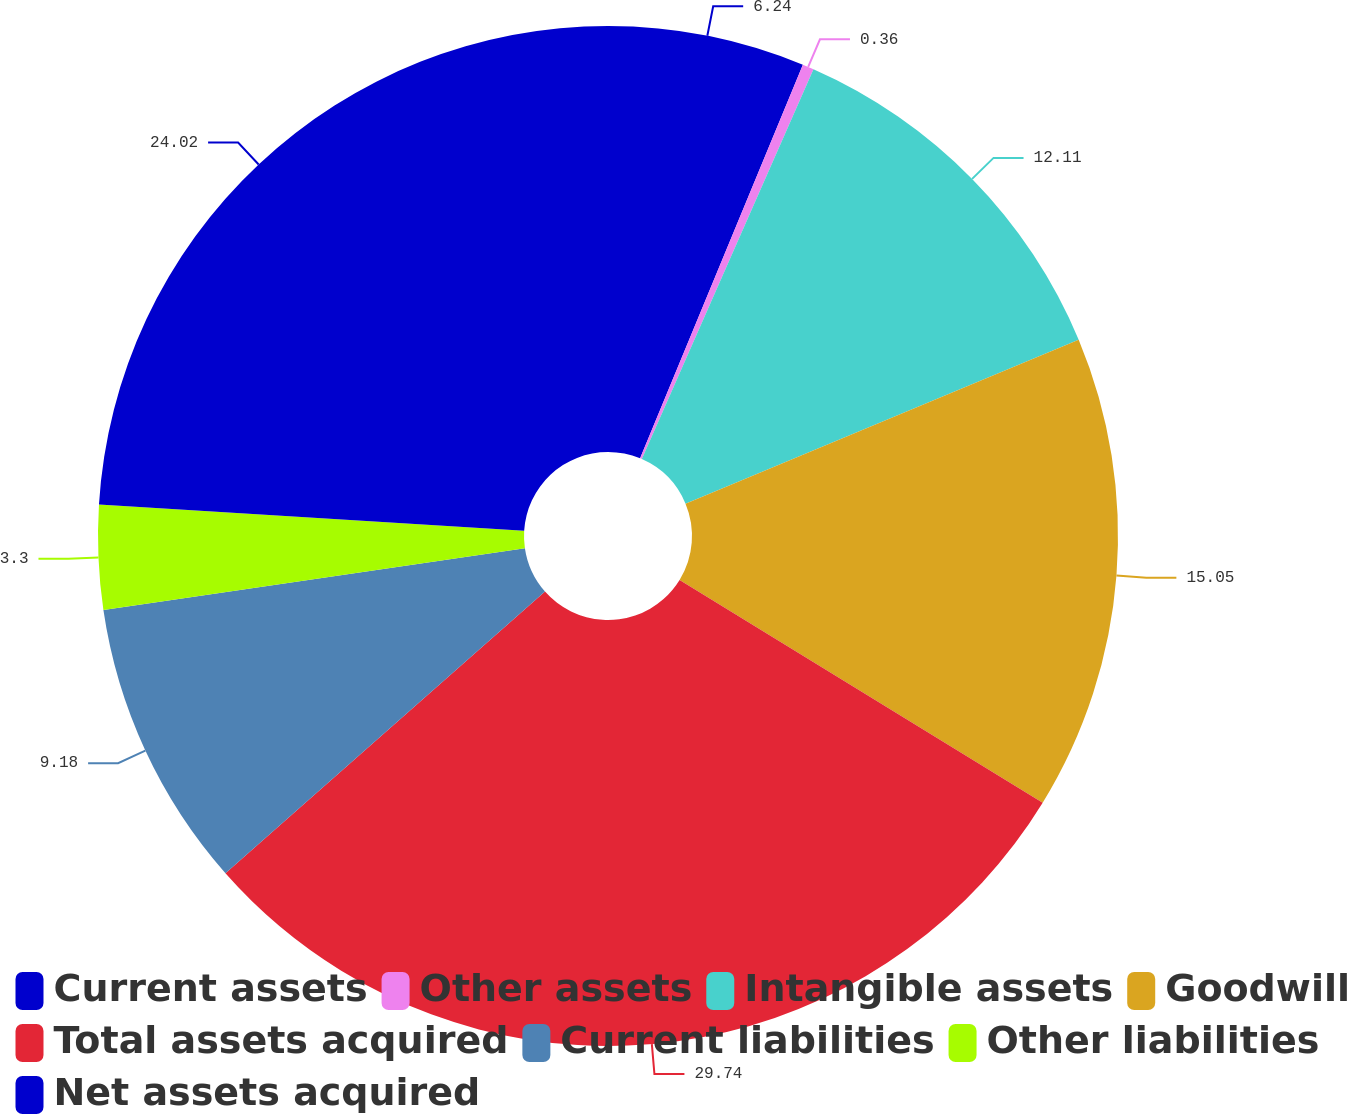Convert chart to OTSL. <chart><loc_0><loc_0><loc_500><loc_500><pie_chart><fcel>Current assets<fcel>Other assets<fcel>Intangible assets<fcel>Goodwill<fcel>Total assets acquired<fcel>Current liabilities<fcel>Other liabilities<fcel>Net assets acquired<nl><fcel>6.24%<fcel>0.36%<fcel>12.11%<fcel>15.05%<fcel>29.74%<fcel>9.18%<fcel>3.3%<fcel>24.02%<nl></chart> 